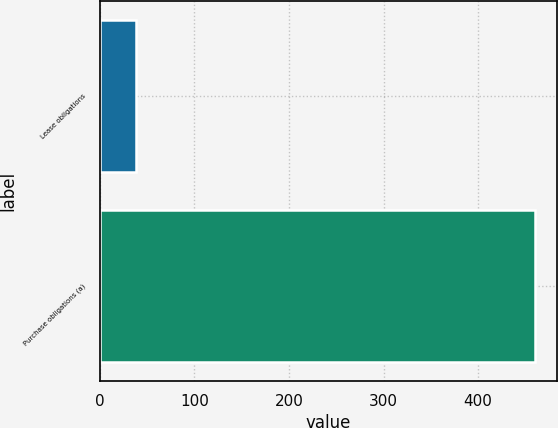Convert chart. <chart><loc_0><loc_0><loc_500><loc_500><bar_chart><fcel>Lease obligations<fcel>Purchase obligations (a)<nl><fcel>38<fcel>460<nl></chart> 